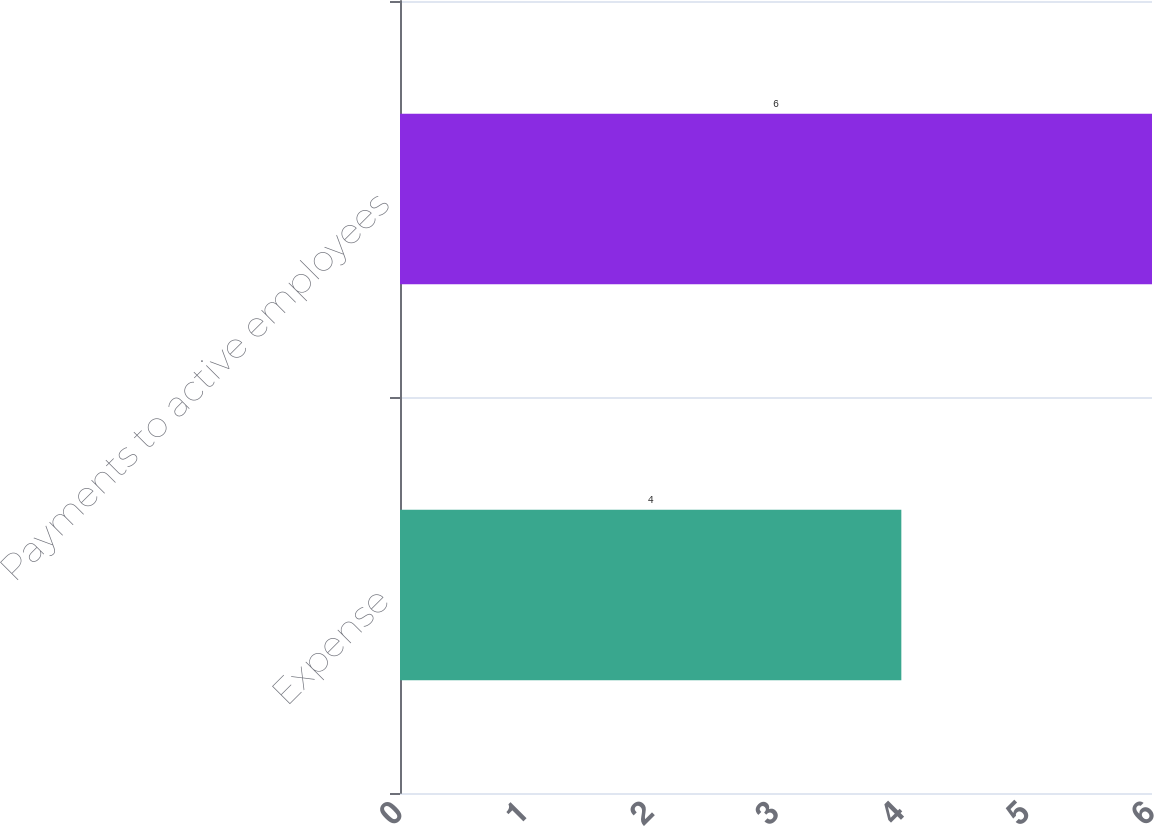Convert chart to OTSL. <chart><loc_0><loc_0><loc_500><loc_500><bar_chart><fcel>Expense<fcel>Payments to active employees<nl><fcel>4<fcel>6<nl></chart> 